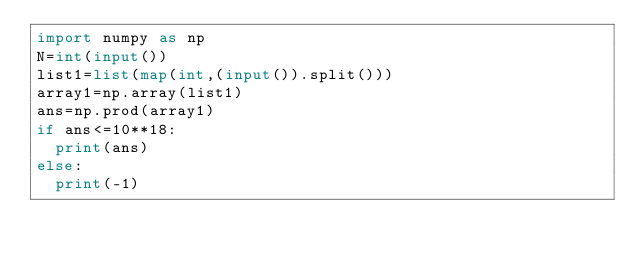Convert code to text. <code><loc_0><loc_0><loc_500><loc_500><_Python_>import numpy as np
N=int(input())
list1=list(map(int,(input()).split()))
array1=np.array(list1)
ans=np.prod(array1)
if ans<=10**18:
  print(ans)
else:
  print(-1)</code> 